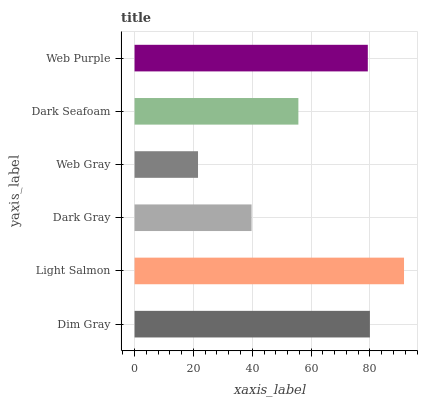Is Web Gray the minimum?
Answer yes or no. Yes. Is Light Salmon the maximum?
Answer yes or no. Yes. Is Dark Gray the minimum?
Answer yes or no. No. Is Dark Gray the maximum?
Answer yes or no. No. Is Light Salmon greater than Dark Gray?
Answer yes or no. Yes. Is Dark Gray less than Light Salmon?
Answer yes or no. Yes. Is Dark Gray greater than Light Salmon?
Answer yes or no. No. Is Light Salmon less than Dark Gray?
Answer yes or no. No. Is Web Purple the high median?
Answer yes or no. Yes. Is Dark Seafoam the low median?
Answer yes or no. Yes. Is Dim Gray the high median?
Answer yes or no. No. Is Dim Gray the low median?
Answer yes or no. No. 